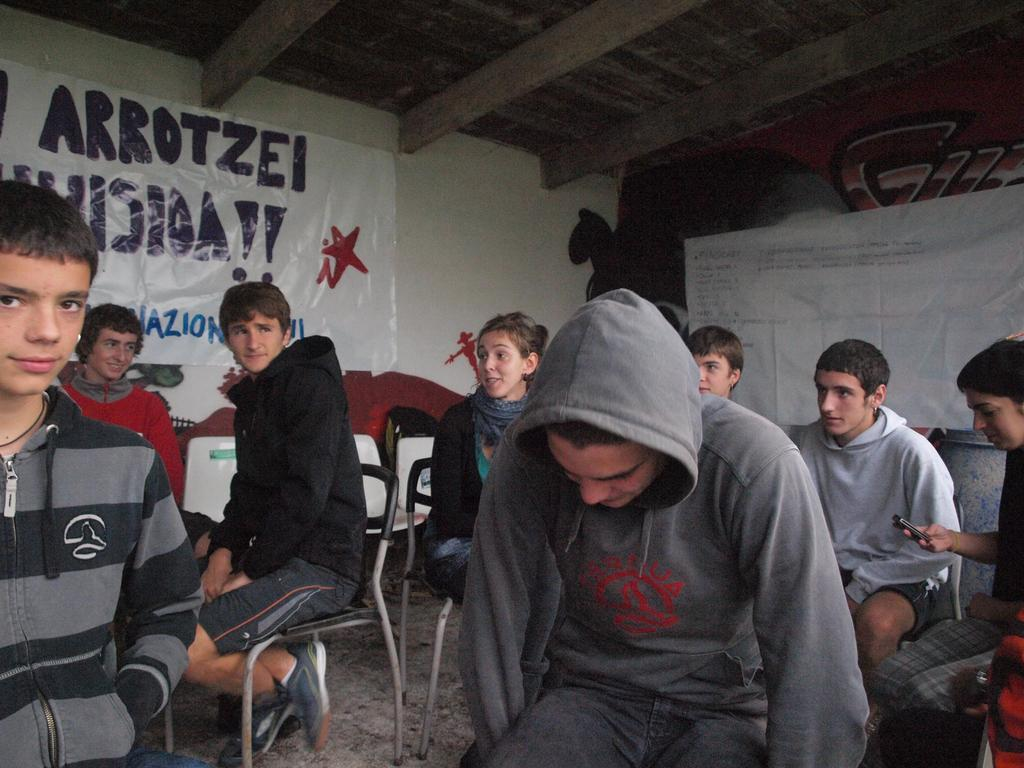What are the people in the image doing? The people in the image are sitting on chairs. What can be seen in the background of the image? There are boards and a wall in the background of the image. What type of rail can be seen in the image? There is no rail present in the image. How many ladybugs are visible on the chairs in the image? There are no ladybugs present in the image. 